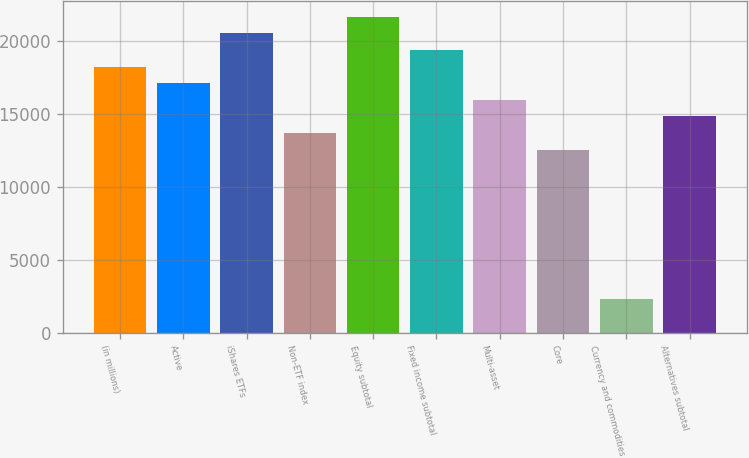Convert chart to OTSL. <chart><loc_0><loc_0><loc_500><loc_500><bar_chart><fcel>(in millions)<fcel>Active<fcel>iShares ETFs<fcel>Non-ETF index<fcel>Equity subtotal<fcel>Fixed income subtotal<fcel>Multi-asset<fcel>Core<fcel>Currency and commodities<fcel>Alternatives subtotal<nl><fcel>18226<fcel>17088.5<fcel>20501<fcel>13676<fcel>21638.5<fcel>19363.5<fcel>15951<fcel>12538.5<fcel>2301<fcel>14813.5<nl></chart> 